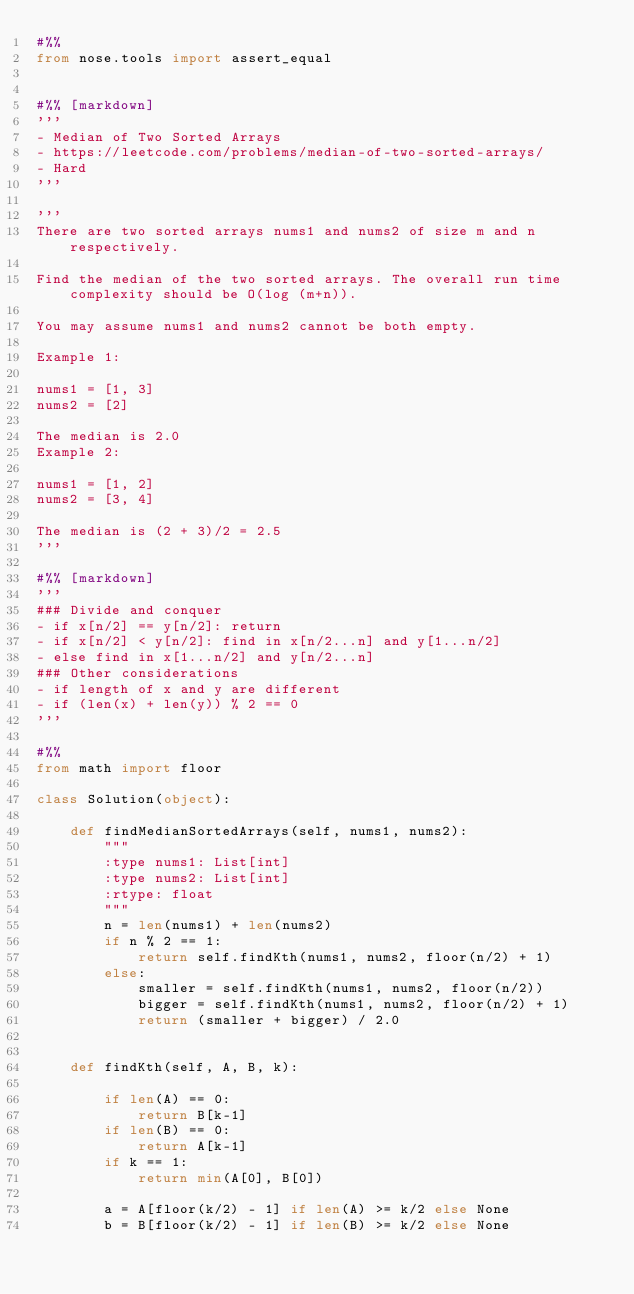Convert code to text. <code><loc_0><loc_0><loc_500><loc_500><_Python_>#%%
from nose.tools import assert_equal


#%% [markdown]
'''
- Median of Two Sorted Arrays
- https://leetcode.com/problems/median-of-two-sorted-arrays/
- Hard
'''

'''
There are two sorted arrays nums1 and nums2 of size m and n respectively.

Find the median of the two sorted arrays. The overall run time complexity should be O(log (m+n)).

You may assume nums1 and nums2 cannot be both empty.

Example 1:

nums1 = [1, 3]
nums2 = [2]

The median is 2.0
Example 2:

nums1 = [1, 2]
nums2 = [3, 4]

The median is (2 + 3)/2 = 2.5
'''

#%% [markdown]
'''
### Divide and conquer
- if x[n/2] == y[n/2]: return
- if x[n/2] < y[n/2]: find in x[n/2...n] and y[1...n/2]
- else find in x[1...n/2] and y[n/2...n]
### Other considerations
- if length of x and y are different
- if (len(x) + len(y)) % 2 == 0
'''

#%%
from math import floor

class Solution(object):

    def findMedianSortedArrays(self, nums1, nums2):
        """
        :type nums1: List[int]
        :type nums2: List[int]
        :rtype: float
        """
        n = len(nums1) + len(nums2)
        if n % 2 == 1:
            return self.findKth(nums1, nums2, floor(n/2) + 1)
        else:
            smaller = self.findKth(nums1, nums2, floor(n/2))
            bigger = self.findKth(nums1, nums2, floor(n/2) + 1)
            return (smaller + bigger) / 2.0


    def findKth(self, A, B, k):

        if len(A) == 0:
            return B[k-1]
        if len(B) == 0:
            return A[k-1]
        if k == 1:
            return min(A[0], B[0])
        
        a = A[floor(k/2) - 1] if len(A) >= k/2 else None
        b = B[floor(k/2) - 1] if len(B) >= k/2 else None</code> 